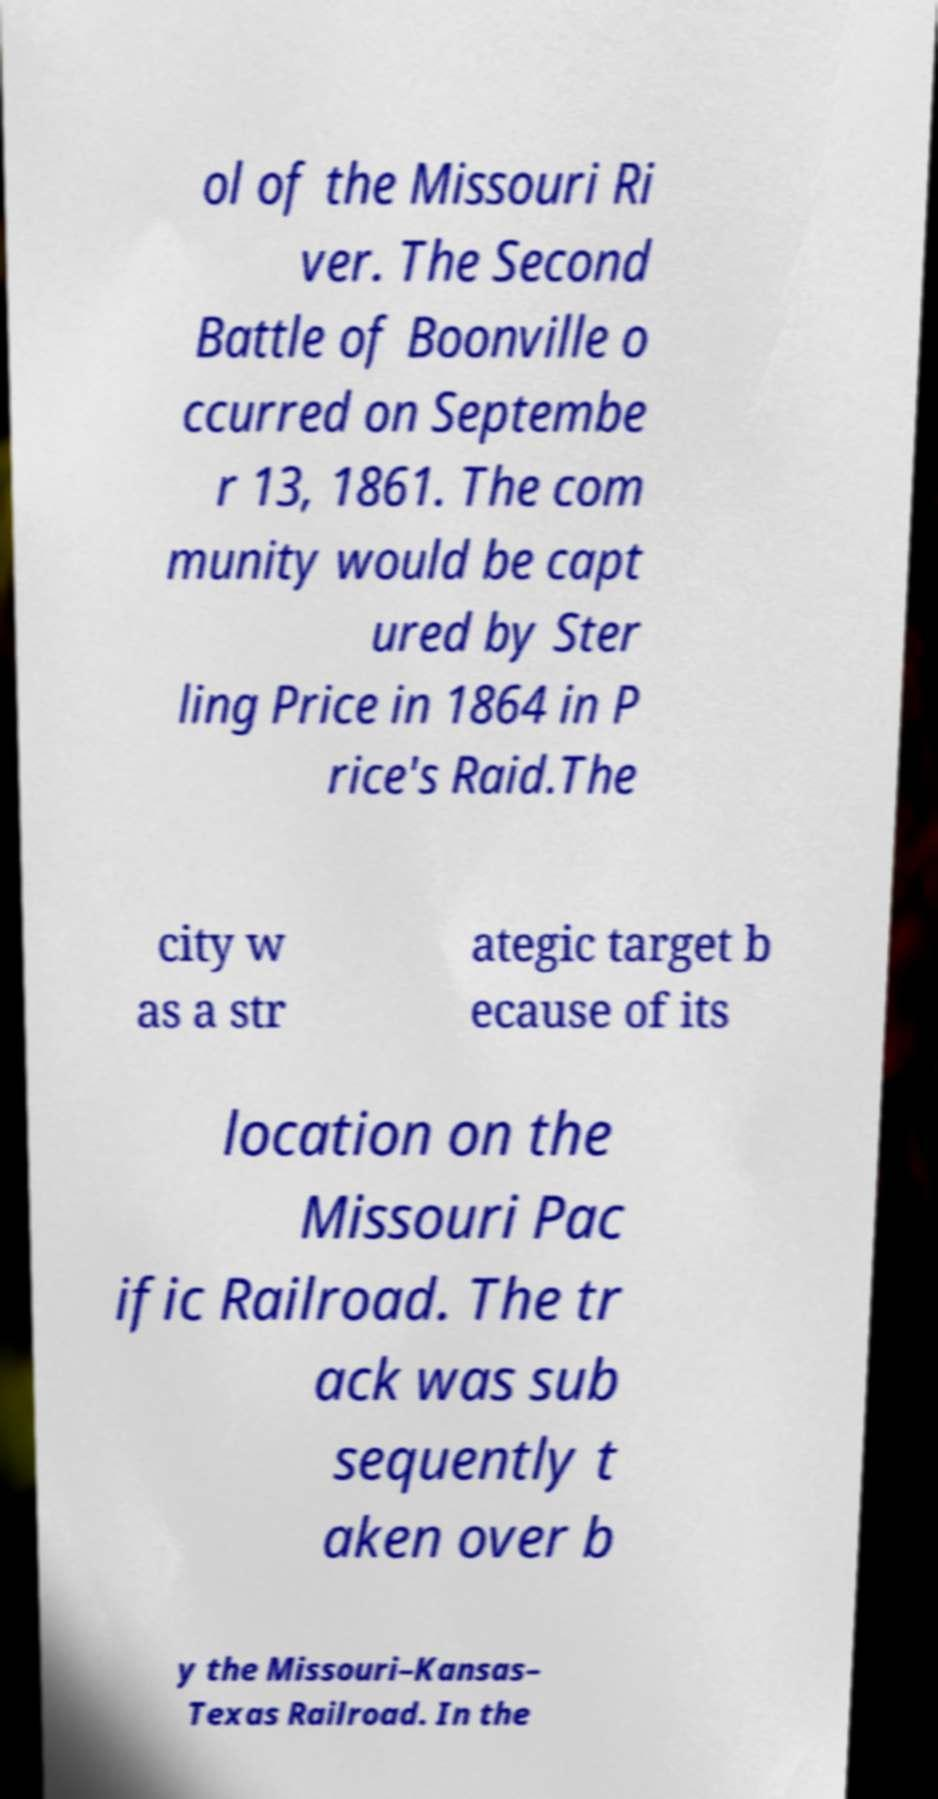Can you accurately transcribe the text from the provided image for me? ol of the Missouri Ri ver. The Second Battle of Boonville o ccurred on Septembe r 13, 1861. The com munity would be capt ured by Ster ling Price in 1864 in P rice's Raid.The city w as a str ategic target b ecause of its location on the Missouri Pac ific Railroad. The tr ack was sub sequently t aken over b y the Missouri–Kansas– Texas Railroad. In the 